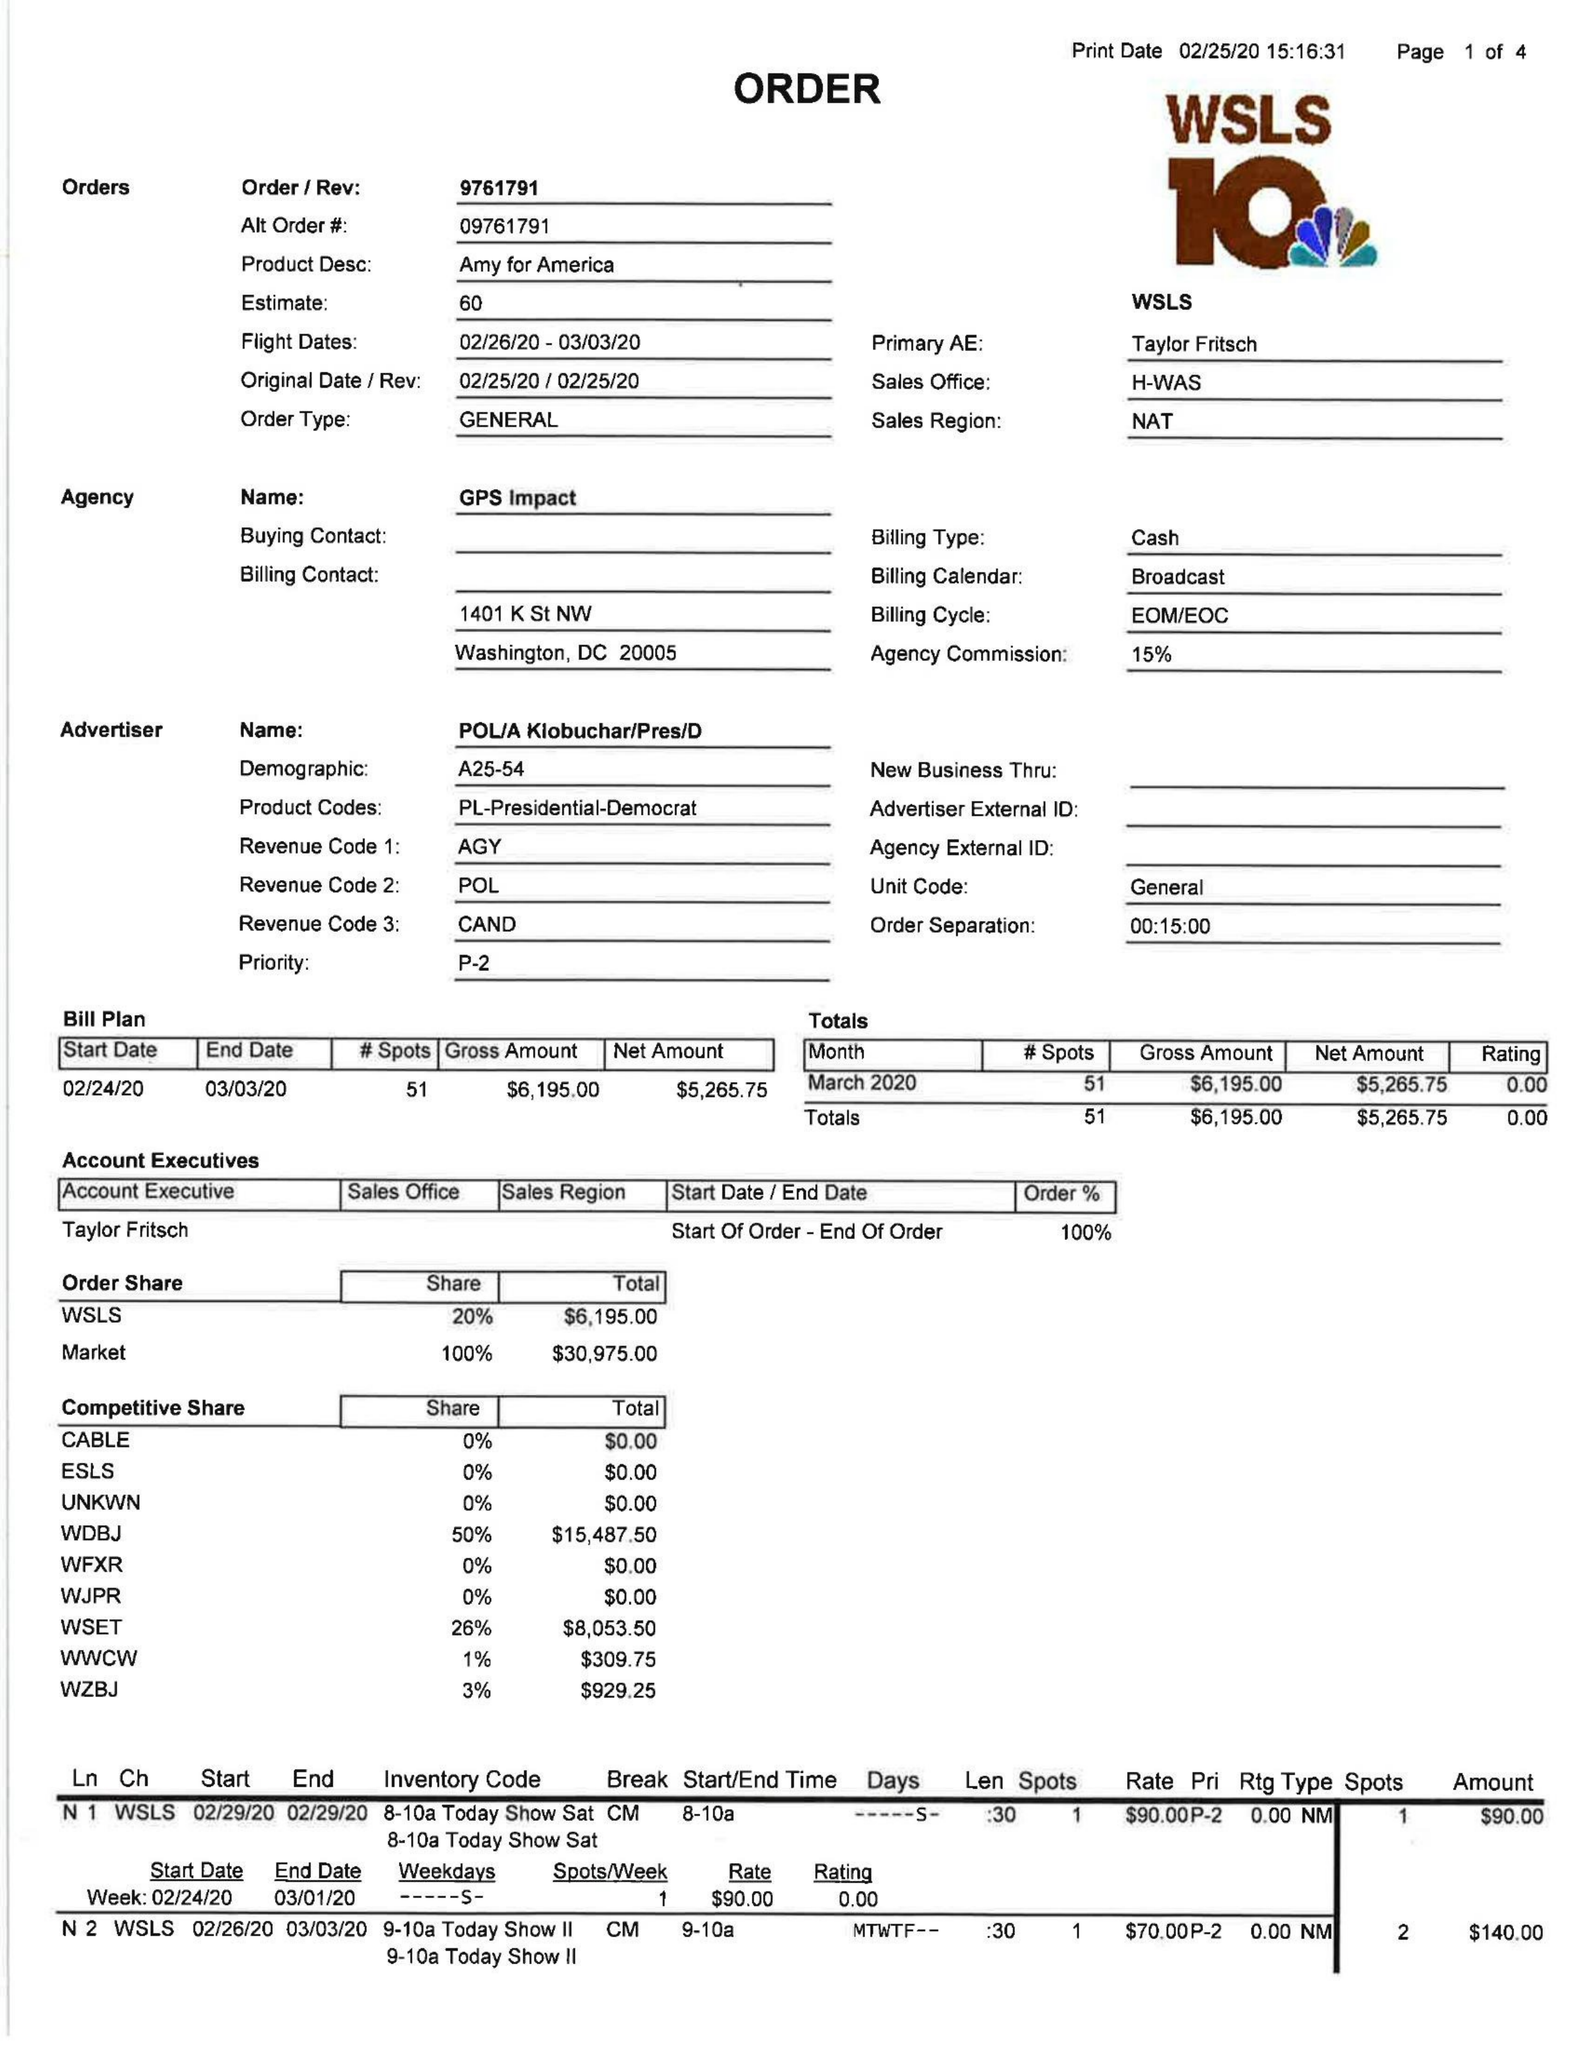What is the value for the flight_to?
Answer the question using a single word or phrase. 03/03/20 